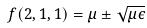<formula> <loc_0><loc_0><loc_500><loc_500>f ( 2 , 1 , 1 ) = \mu \pm \sqrt { \mu \epsilon }</formula> 